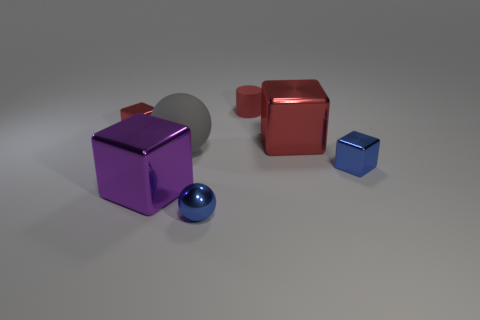Can you describe the lighting and shadows in the image? Certainly. The lighting in the image appears to be diffused, coming from the upper right area, creating soft shadows to the left and beneath the objects. The cast shadows are not harsh, suggesting a non-direct light source, possibly an overcast sky or a softbox used in a studio setting. 